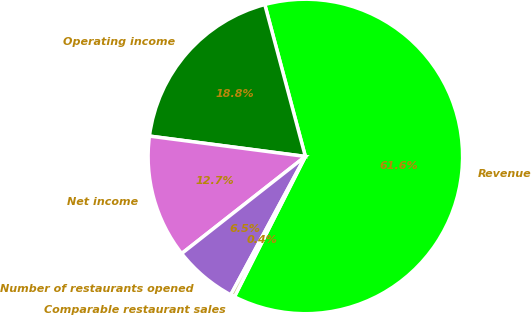Convert chart to OTSL. <chart><loc_0><loc_0><loc_500><loc_500><pie_chart><fcel>Revenue<fcel>Operating income<fcel>Net income<fcel>Number of restaurants opened<fcel>Comparable restaurant sales<nl><fcel>61.6%<fcel>18.78%<fcel>12.66%<fcel>6.54%<fcel>0.42%<nl></chart> 